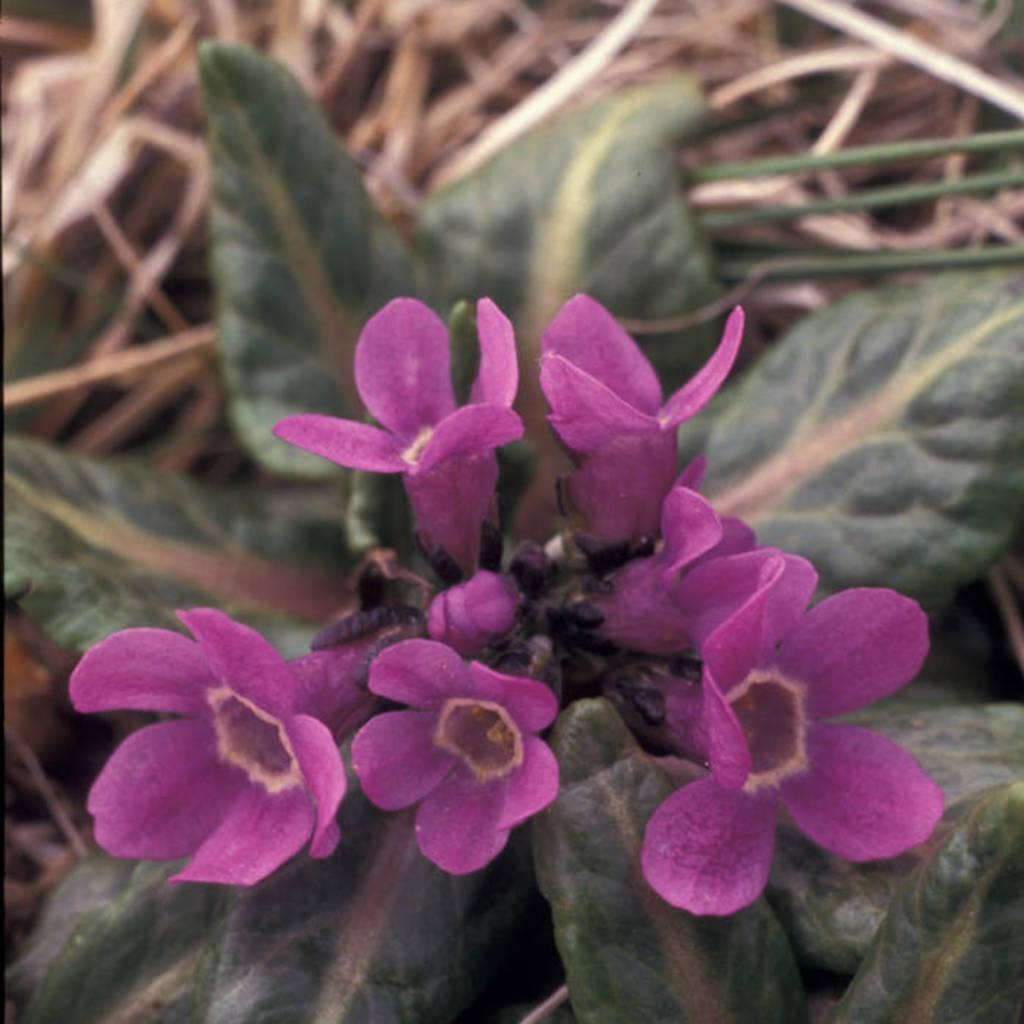What type of plant is visible in the image? There is a plant in the image, and it has leaves. Are there any flowers on the plant? Yes, the plant has violet flowers. What can be seen in the background of the image? In the background, there appears to be dried grass. How does the wind affect the cup in the image? There is no cup present in the image, so the wind's effect cannot be determined. 